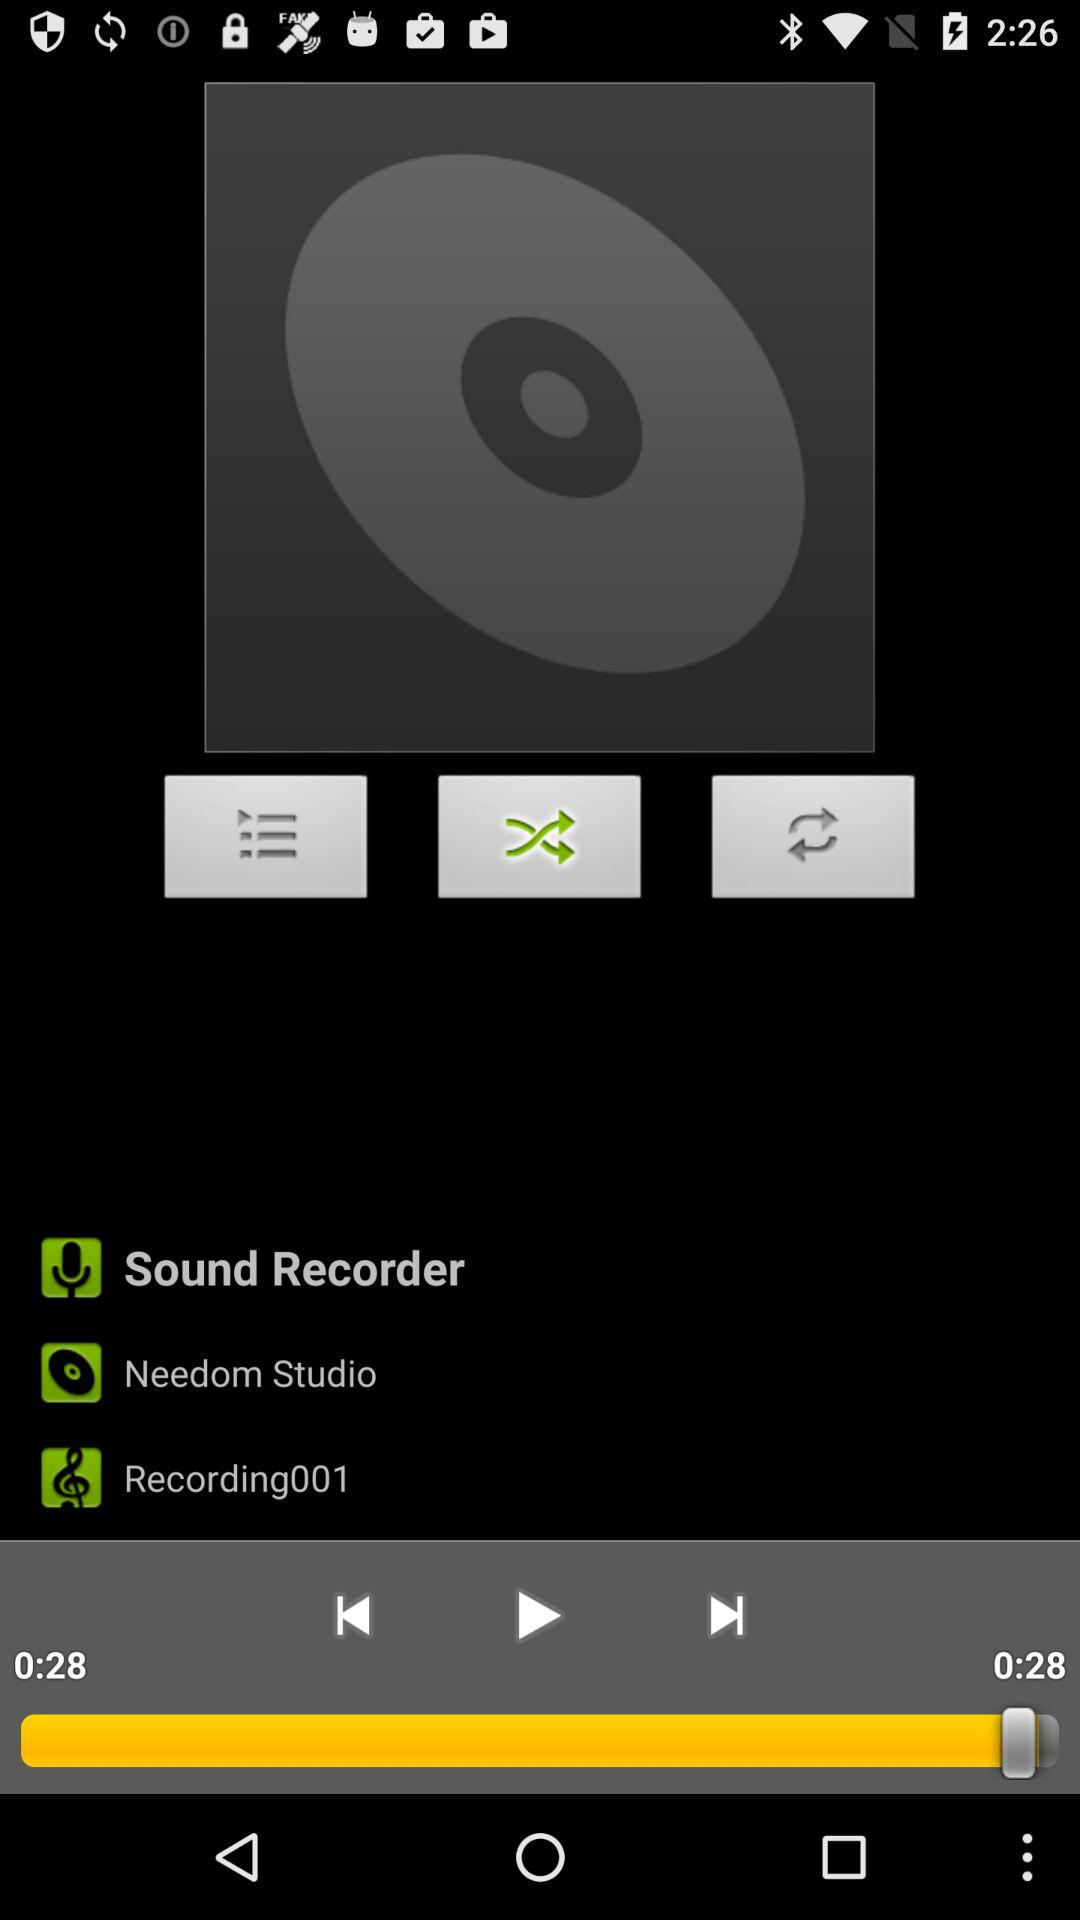What is the duration of the last played sound? The duration is 28 seconds. 